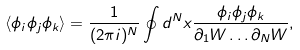<formula> <loc_0><loc_0><loc_500><loc_500>\langle \phi _ { i } \phi _ { j } \phi _ { k } \rangle & = \frac { 1 } { ( 2 \pi i ) ^ { N } } \oint d ^ { N } x \frac { \phi _ { i } \phi _ { j } \phi _ { k } } { \partial _ { 1 } W \dots \partial _ { N } W } ,</formula> 